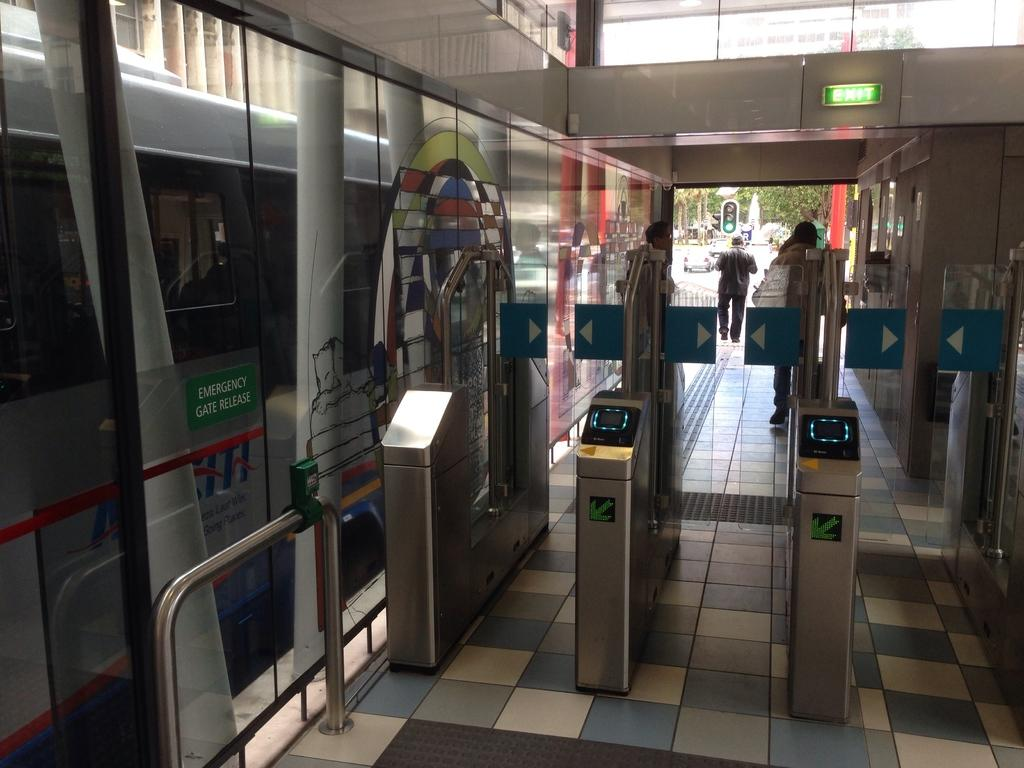Provide a one-sentence caption for the provided image. The silver bus has a green sign labeled Emergency Gate Release. 